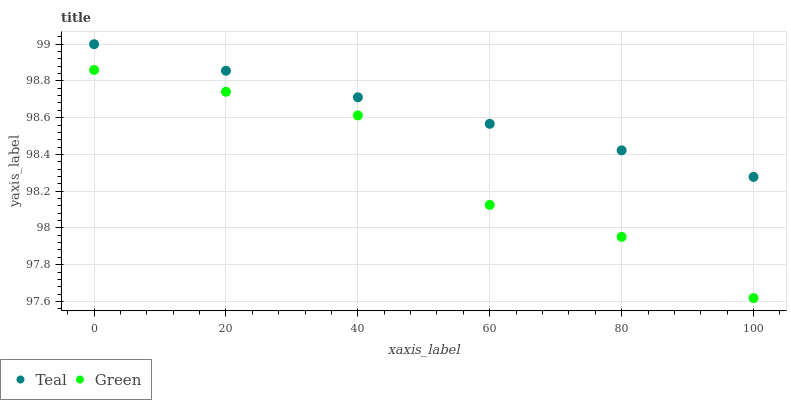Does Green have the minimum area under the curve?
Answer yes or no. Yes. Does Teal have the maximum area under the curve?
Answer yes or no. Yes. Does Teal have the minimum area under the curve?
Answer yes or no. No. Is Teal the smoothest?
Answer yes or no. Yes. Is Green the roughest?
Answer yes or no. Yes. Is Teal the roughest?
Answer yes or no. No. Does Green have the lowest value?
Answer yes or no. Yes. Does Teal have the lowest value?
Answer yes or no. No. Does Teal have the highest value?
Answer yes or no. Yes. Is Green less than Teal?
Answer yes or no. Yes. Is Teal greater than Green?
Answer yes or no. Yes. Does Green intersect Teal?
Answer yes or no. No. 